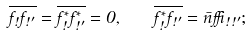Convert formula to latex. <formula><loc_0><loc_0><loc_500><loc_500>\overline { f _ { \omega } f _ { \omega ^ { \prime } } } = \overline { f _ { \omega } ^ { * } f _ { \omega ^ { \prime } } ^ { * } } = 0 , \quad \overline { f _ { \omega } ^ { * } f _ { \omega ^ { \prime } } } = \bar { n } \delta _ { \omega \omega ^ { \prime } } ;</formula> 